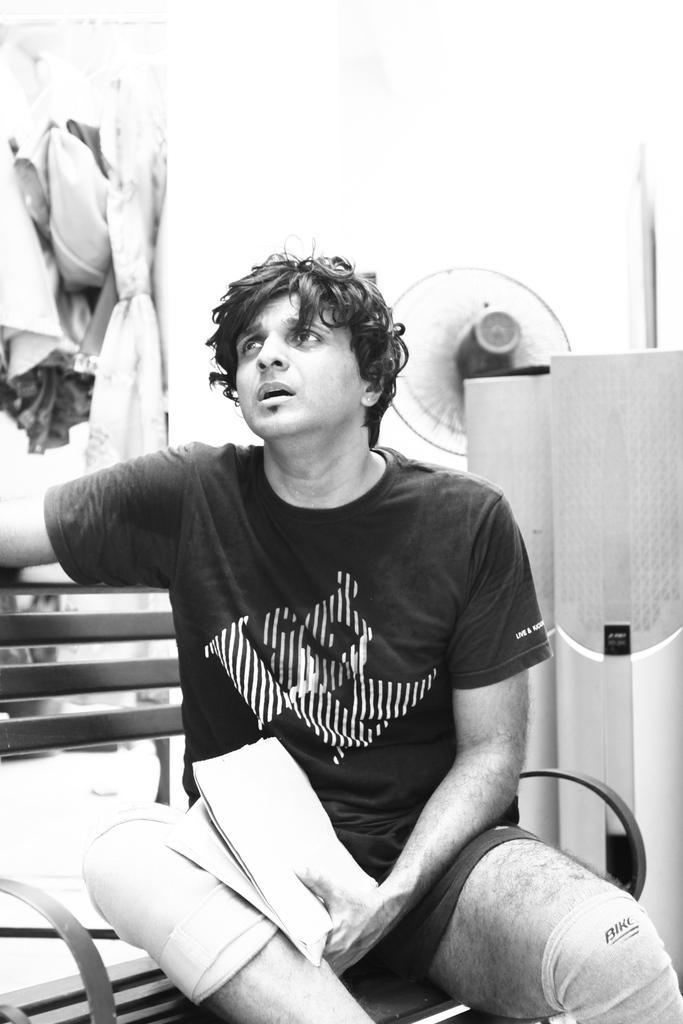In one or two sentences, can you explain what this image depicts? In this image in the foreground I can see the person sitting on the bench and he holds something in his left hand. 